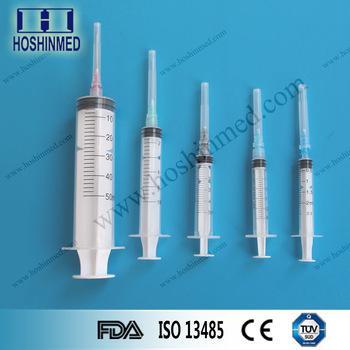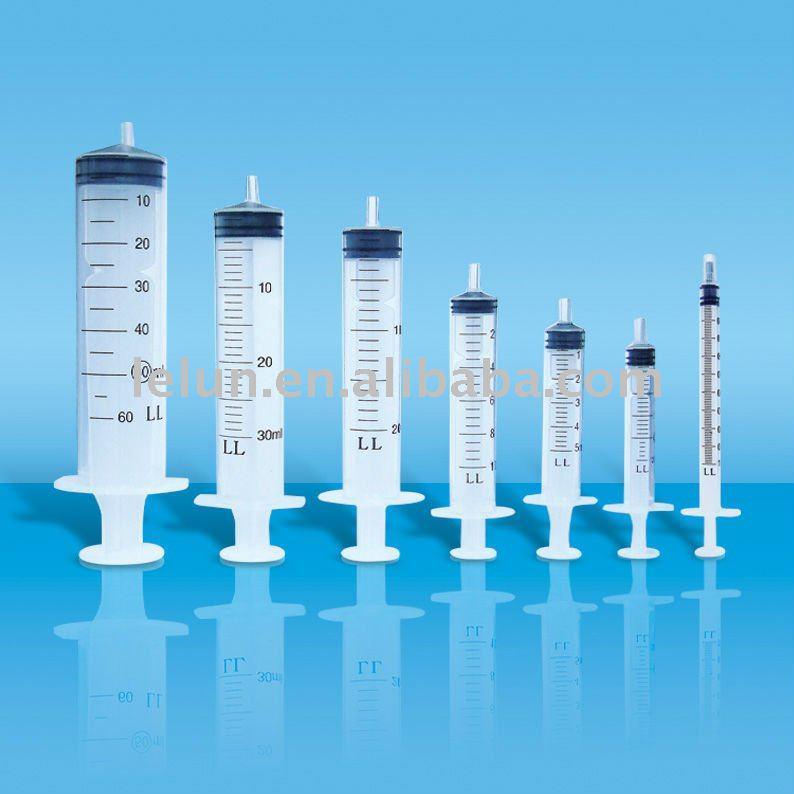The first image is the image on the left, the second image is the image on the right. Examine the images to the left and right. Is the description "One of the images has exactly 7 syringes." accurate? Answer yes or no. Yes. The first image is the image on the left, the second image is the image on the right. Analyze the images presented: Is the assertion "Right image shows syringes arranged big to small, with the biggest in volume on the left." valid? Answer yes or no. Yes. 